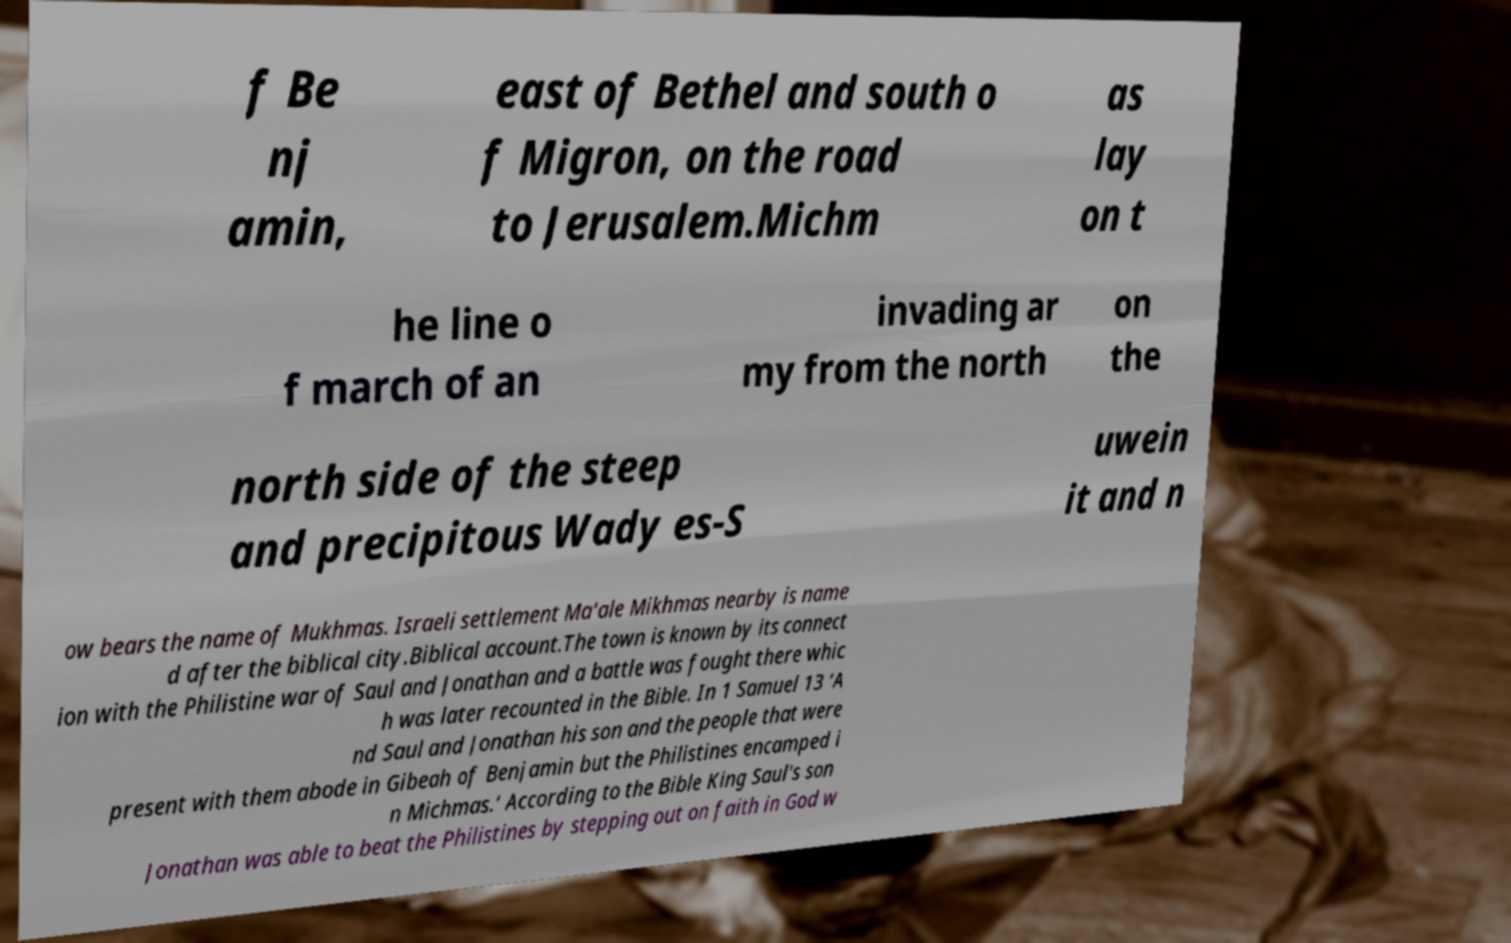There's text embedded in this image that I need extracted. Can you transcribe it verbatim? f Be nj amin, east of Bethel and south o f Migron, on the road to Jerusalem.Michm as lay on t he line o f march of an invading ar my from the north on the north side of the steep and precipitous Wady es-S uwein it and n ow bears the name of Mukhmas. Israeli settlement Ma'ale Mikhmas nearby is name d after the biblical city.Biblical account.The town is known by its connect ion with the Philistine war of Saul and Jonathan and a battle was fought there whic h was later recounted in the Bible. In 1 Samuel 13 ‘A nd Saul and Jonathan his son and the people that were present with them abode in Gibeah of Benjamin but the Philistines encamped i n Michmas.’ According to the Bible King Saul's son Jonathan was able to beat the Philistines by stepping out on faith in God w 